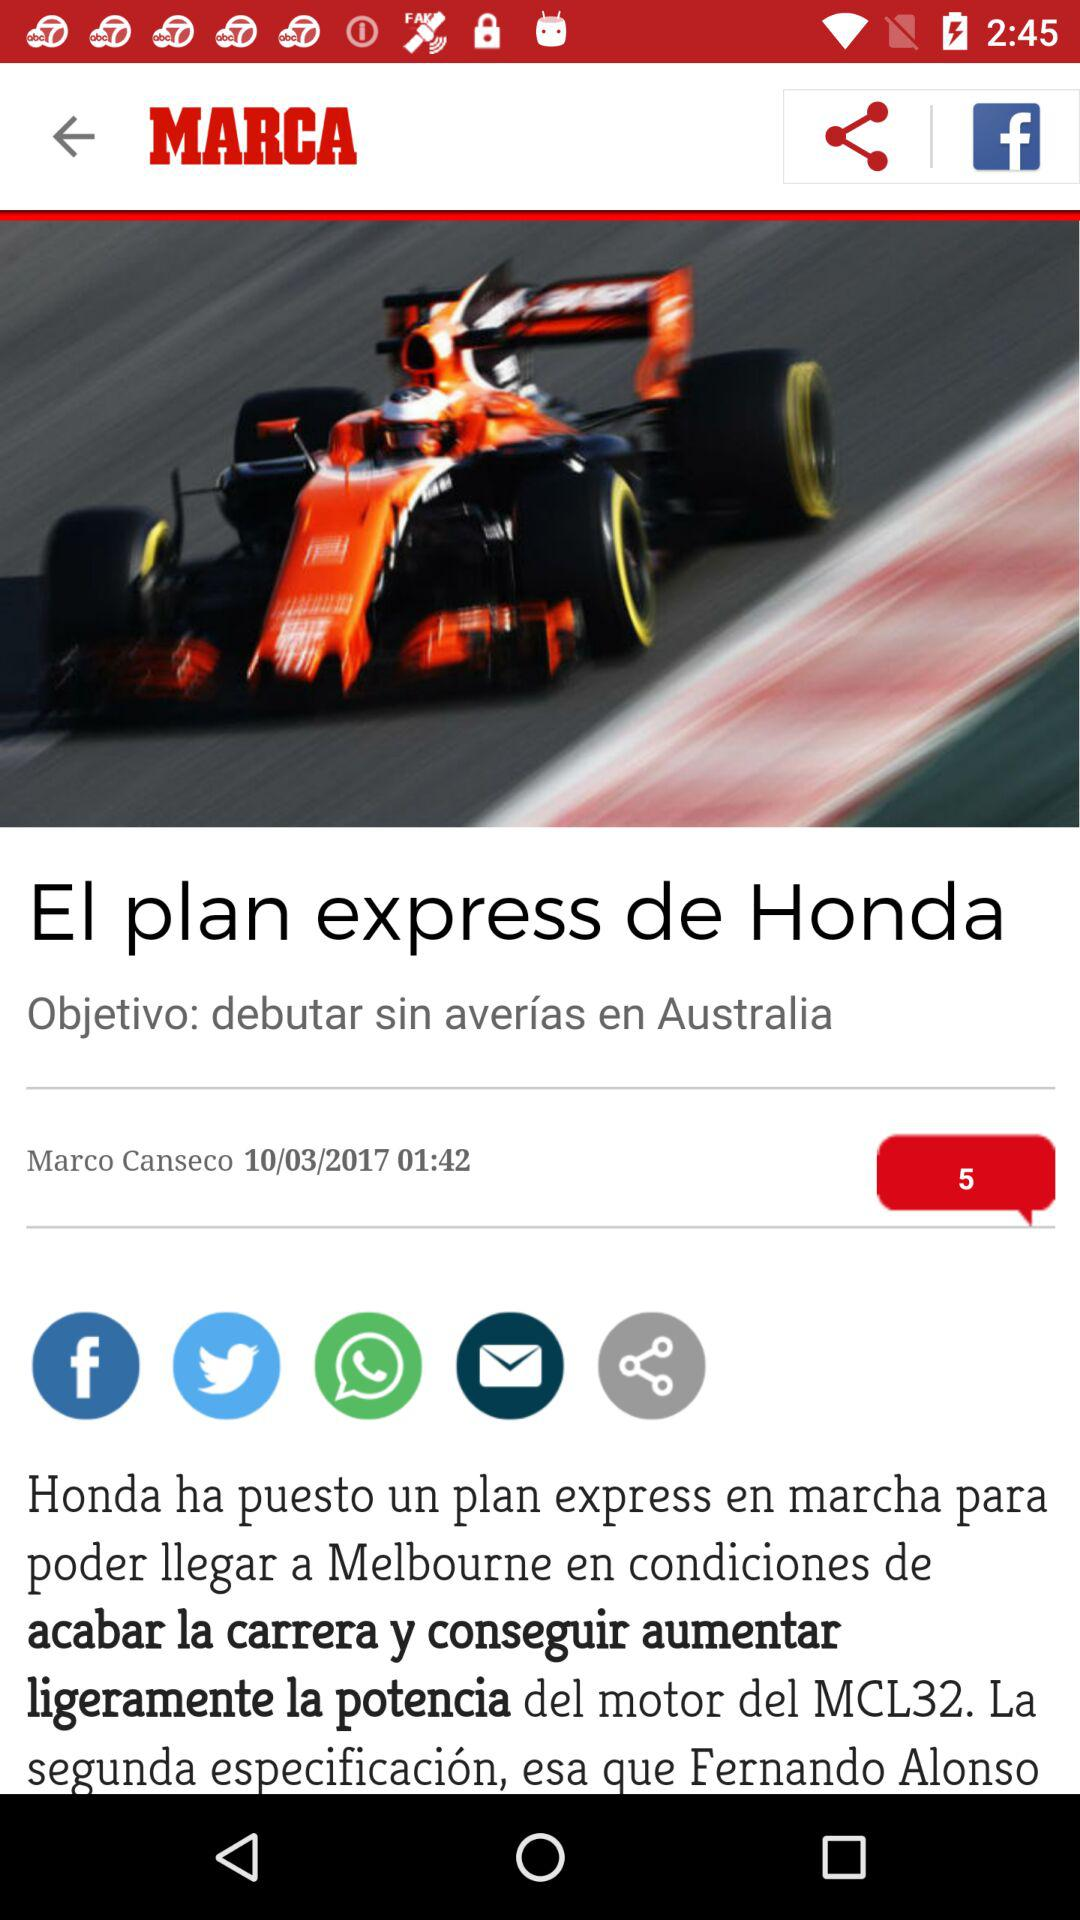What is the publication date? The publication date is 10/03/2017. 